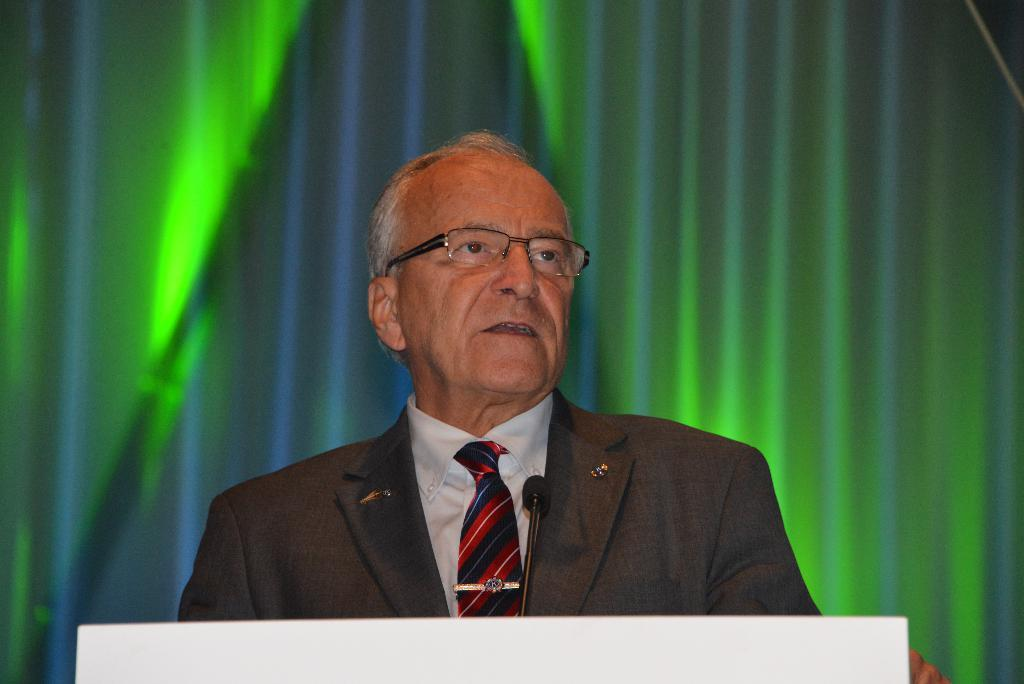Who is the person in the image? There is a man in the image. What can be seen on the man's face? The man is wearing spectacles. What is the man wearing? The man is wearing a suit. What object is in front of the man? There is a microphone in front of the man. What can be seen in the background of the image? There is a curtain in the background of the image. What type of pot is visible on the man's head in the image? There is no pot visible on the man's head in the image. What kind of shock can be seen affecting the man in the image? There is no shock or any indication of an electrical disturbance in the image. 